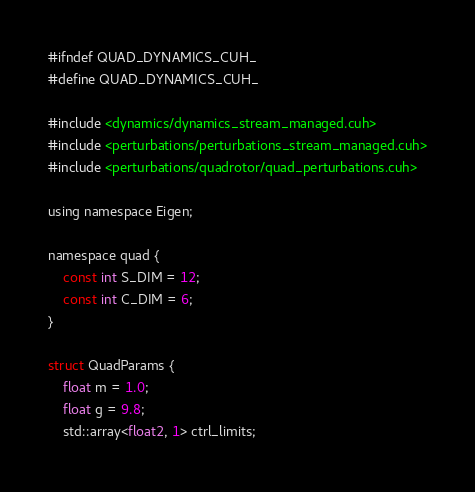<code> <loc_0><loc_0><loc_500><loc_500><_Cuda_>#ifndef QUAD_DYNAMICS_CUH_
#define QUAD_DYNAMICS_CUH_

#include <dynamics/dynamics_stream_managed.cuh>
#include <perturbations/perturbations_stream_managed.cuh>
#include <perturbations/quadrotor/quad_perturbations.cuh>

using namespace Eigen;

namespace quad {
	const int S_DIM = 12;
	const int C_DIM = 6;
}

struct QuadParams {
	float m = 1.0;
	float g = 9.8;
	std::array<float2, 1> ctrl_limits;
</code> 